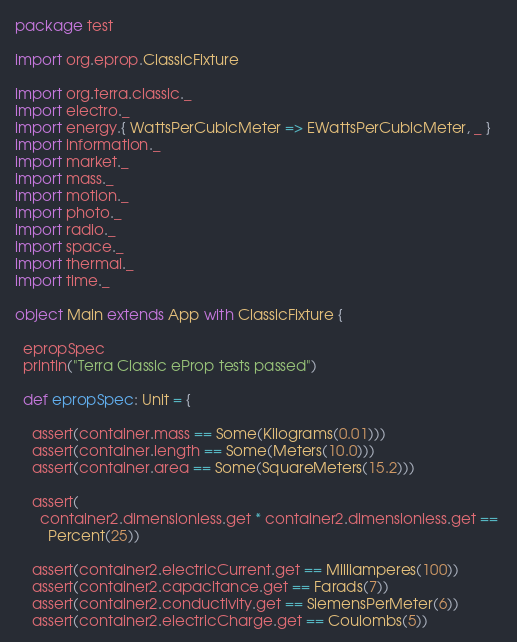Convert code to text. <code><loc_0><loc_0><loc_500><loc_500><_Scala_>
package test

import org.eprop.ClassicFixture

import org.terra.classic._
import electro._
import energy.{ WattsPerCubicMeter => EWattsPerCubicMeter, _ }
import information._
import market._
import mass._
import motion._
import photo._
import radio._
import space._
import thermal._
import time._

object Main extends App with ClassicFixture {

  epropSpec
  println("Terra Classic eProp tests passed")

  def epropSpec: Unit = {

    assert(container.mass == Some(Kilograms(0.01)))
    assert(container.length == Some(Meters(10.0)))
    assert(container.area == Some(SquareMeters(15.2)))

    assert(
      container2.dimensionless.get * container2.dimensionless.get == 
        Percent(25))

    assert(container2.electricCurrent.get == Milliamperes(100))
    assert(container2.capacitance.get == Farads(7))
    assert(container2.conductivity.get == SiemensPerMeter(6))
    assert(container2.electricCharge.get == Coulombs(5))</code> 